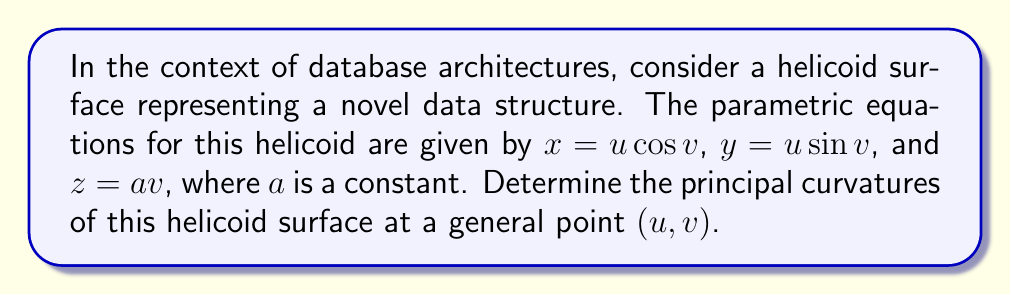Could you help me with this problem? To find the principal curvatures of the helicoid surface, we'll follow these steps:

1) First, we need to calculate the first fundamental form coefficients (E, F, G) and the second fundamental form coefficients (L, M, N).

2) The parametric equations are:
   $\mathbf{r}(u,v) = (u \cos v, u \sin v, av)$

3) Calculate the partial derivatives:
   $\mathbf{r}_u = (\cos v, \sin v, 0)$
   $\mathbf{r}_v = (-u \sin v, u \cos v, a)$

4) Calculate E, F, and G:
   $E = \mathbf{r}_u \cdot \mathbf{r}_u = \cos^2 v + \sin^2 v = 1$
   $F = \mathbf{r}_u \cdot \mathbf{r}_v = 0$
   $G = \mathbf{r}_v \cdot \mathbf{r}_v = u^2 \sin^2 v + u^2 \cos^2 v + a^2 = u^2 + a^2$

5) Calculate the unit normal vector:
   $\mathbf{N} = \frac{\mathbf{r}_u \times \mathbf{r}_v}{|\mathbf{r}_u \times \mathbf{r}_v|} = \frac{(a \sin v, -a \cos v, u)}{\sqrt{a^2 + u^2}}$

6) Calculate the second partial derivatives:
   $\mathbf{r}_{uu} = (0, 0, 0)$
   $\mathbf{r}_{uv} = (-\sin v, \cos v, 0)$
   $\mathbf{r}_{vv} = (-u \cos v, -u \sin v, 0)$

7) Calculate L, M, and N:
   $L = \mathbf{r}_{uu} \cdot \mathbf{N} = 0$
   $M = \mathbf{r}_{uv} \cdot \mathbf{N} = \frac{-a}{\sqrt{a^2 + u^2}}$
   $N = \mathbf{r}_{vv} \cdot \mathbf{N} = \frac{-au}{\sqrt{a^2 + u^2}}$

8) The principal curvatures are the eigenvalues of the shape operator. They can be found by solving the characteristic equation:
   $\det(II - \kappa I) = 0$

   Where II is the second fundamental form matrix and I is the first fundamental form matrix:

   $II = \begin{pmatrix} 0 & -\frac{a}{\sqrt{a^2 + u^2}} \\ -\frac{a}{\sqrt{a^2 + u^2}} & -\frac{au}{\sqrt{a^2 + u^2}} \end{pmatrix}$

   $I = \begin{pmatrix} 1 & 0 \\ 0 & u^2 + a^2 \end{pmatrix}$

9) Solving the characteristic equation:

   $\det \begin{pmatrix} -\kappa & -\frac{a}{\sqrt{a^2 + u^2}} \\ -\frac{a}{\sqrt{a^2 + u^2}} & -\frac{au}{\sqrt{a^2 + u^2}} - \kappa(u^2 + a^2) \end{pmatrix} = 0$

   $\kappa^2(u^2 + a^2) + \frac{au\kappa}{\sqrt{a^2 + u^2}} - \frac{a^2}{a^2 + u^2} = 0$

10) Solving this quadratic equation in $\kappa$, we get the principal curvatures:

    $\kappa_1 = \frac{a}{(a^2 + u^2)\sqrt{a^2 + u^2}}$
    $\kappa_2 = -\frac{a}{(a^2 + u^2)\sqrt{a^2 + u^2}}$
Answer: $\kappa_1 = \frac{a}{(a^2 + u^2)\sqrt{a^2 + u^2}}$, $\kappa_2 = -\frac{a}{(a^2 + u^2)\sqrt{a^2 + u^2}}$ 